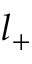<formula> <loc_0><loc_0><loc_500><loc_500>l _ { + }</formula> 